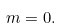<formula> <loc_0><loc_0><loc_500><loc_500>m = 0 .</formula> 